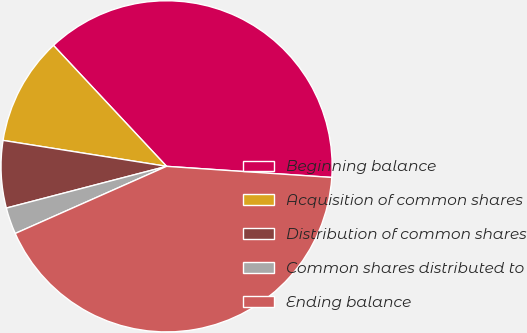<chart> <loc_0><loc_0><loc_500><loc_500><pie_chart><fcel>Beginning balance<fcel>Acquisition of common shares<fcel>Distribution of common shares<fcel>Common shares distributed to<fcel>Ending balance<nl><fcel>38.04%<fcel>10.53%<fcel>6.56%<fcel>2.59%<fcel>42.29%<nl></chart> 